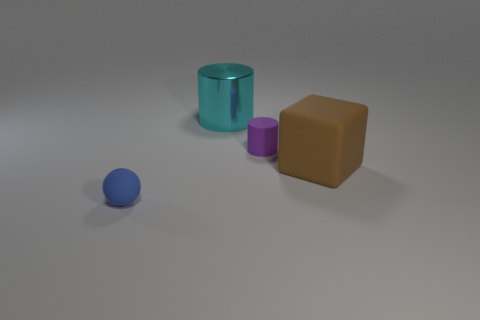How many objects are tiny blue shiny cubes or tiny cylinders?
Your response must be concise. 1. There is a thing on the left side of the big cylinder; is it the same size as the rubber object that is behind the block?
Your answer should be compact. Yes. How many cylinders are blue objects or large shiny things?
Your answer should be compact. 1. Are any big gray rubber objects visible?
Offer a terse response. No. Are there any other things that are the same shape as the cyan thing?
Offer a terse response. Yes. Is the big metal cylinder the same color as the tiny ball?
Give a very brief answer. No. How many objects are either large things on the right side of the tiny cylinder or yellow matte things?
Ensure brevity in your answer.  1. There is a small matte object to the left of the small matte object behind the large brown rubber object; what number of small rubber balls are in front of it?
Provide a succinct answer. 0. Is there anything else that is the same size as the matte cube?
Your answer should be compact. Yes. There is a small matte thing that is in front of the rubber thing that is behind the large object that is in front of the tiny purple rubber object; what shape is it?
Your answer should be compact. Sphere. 